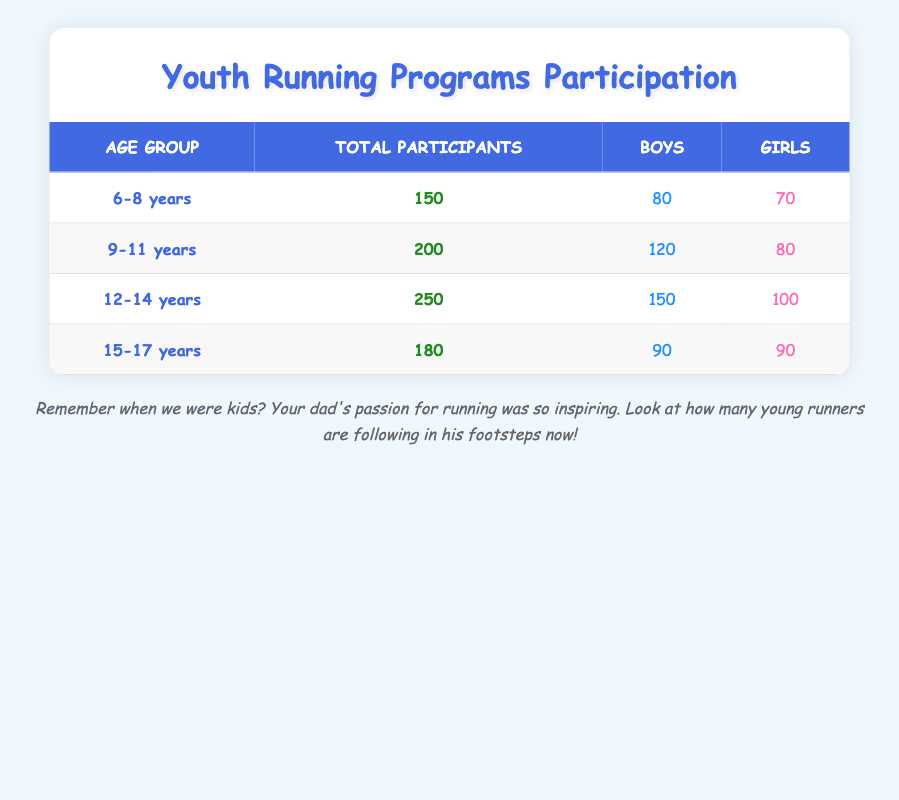What is the total number of participants in the 12-14 age group? The table indicates that the total number of participants for the 12-14 age group is explicitly listed under the "Total Participants" column. By referring to that column, we can see that it is 250.
Answer: 250 How many more boys participated than girls in the 9-11 age group? To find this, we look at the number of boys (120) and girls (80) in the 9-11 age group. We subtract the number of girls from the number of boys: 120 - 80 = 40.
Answer: 40 Is the total number of participants in the 6-8 age group greater than in the 15-17 age group? The total participants for the 6-8 age group is 150, while for the 15-17 age group, it is 180. Since 150 is less than 180, the statement is false.
Answer: No What is the total number of participants across all age groups? To determine this, we sum the total participants from each age group: 150 (6-8) + 200 (9-11) + 250 (12-14) + 180 (15-17) = 780.
Answer: 780 Are there an equal number of boys and girls in the 15-17 age group? In the 15-17 age group, the number of boys is 90 and the number of girls is also 90. Since these numbers are the same, the answer is yes.
Answer: Yes What is the average number of participants for boys across all age groups? First, we need to find the total number of boys from all age groups: 80 (6-8) + 120 (9-11) + 150 (12-14) + 90 (15-17) = 440 boys. There are 4 age groups; thus, the average is 440 / 4 = 110.
Answer: 110 How many total girls participated in youth running programs in the 6-8 and 12-14 age groups combined? We need to add the number of girls in the 6-8 age group (70) to the number in the 12-14 age group (100). Therefore, 70 + 100 = 170 total girls.
Answer: 170 In which age group did boys have the highest number of participants? By examining the boys' figures across the age groups: 80 (6-8), 120 (9-11), 150 (12-14), and 90 (15-17). The highest total is 150 in the 12-14 age group.
Answer: 12-14 years How many participants are there in the age group with the least total participants? The 6-8 age group has the fewest total participants at 150 when compared to the other age groups.
Answer: 150 